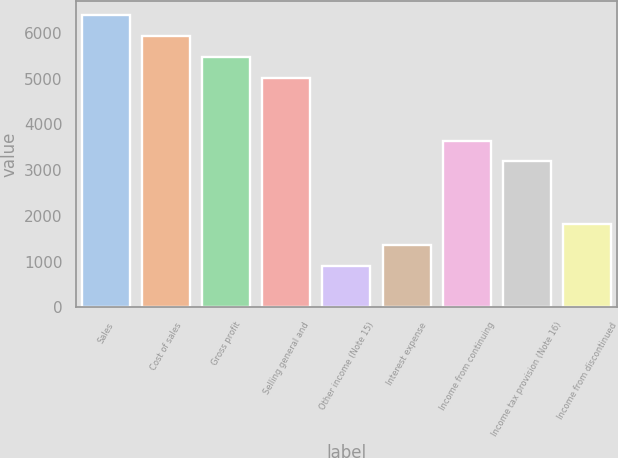Convert chart to OTSL. <chart><loc_0><loc_0><loc_500><loc_500><bar_chart><fcel>Sales<fcel>Cost of sales<fcel>Gross profit<fcel>Selling general and<fcel>Other income (Note 15)<fcel>Interest expense<fcel>Income from continuing<fcel>Income tax provision (Note 16)<fcel>Income from discontinued<nl><fcel>6378.8<fcel>5923.21<fcel>5467.62<fcel>5012.03<fcel>911.72<fcel>1367.31<fcel>3645.26<fcel>3189.67<fcel>1822.9<nl></chart> 